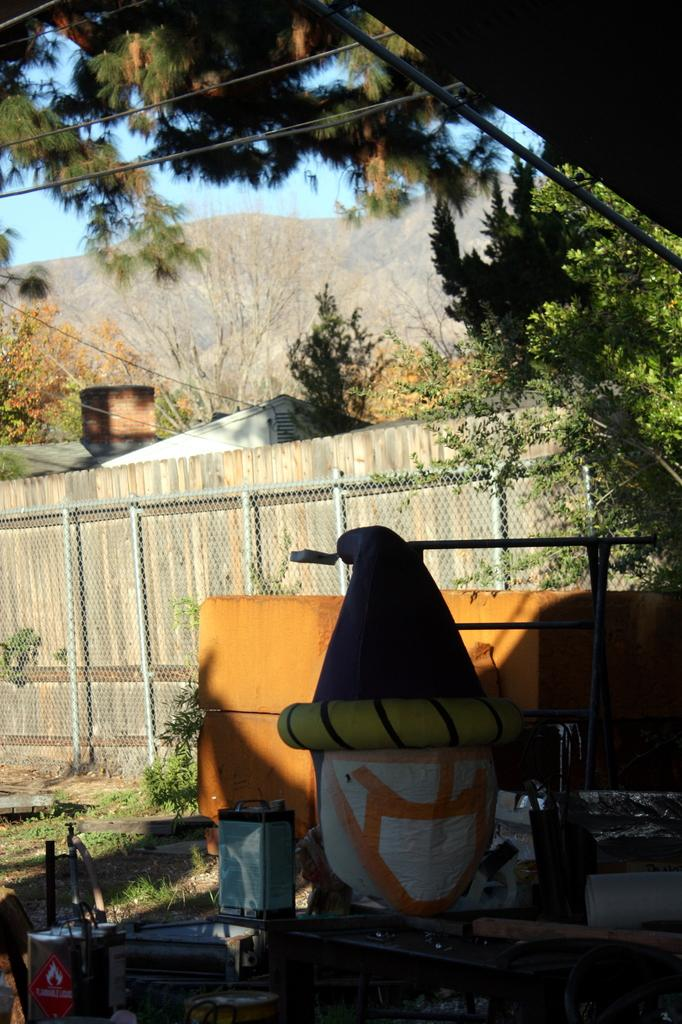What type of objects can be seen in the image? There are cans in the image. Can you describe the color of one of the objects in the image? There is a brown colored object in the image. What type of structure can be seen in the image? There is fencing and a wall in the image. What type of natural elements can be seen in the image? There are trees and a mountain visible in the image. What is visible in the background of the image? The sky is visible in the background of the image. Can you identify any man-made structures in the image? There is a house in the image. What type of theory can be seen being tested in the image? There is no theory being tested in the image; it contains cans, a brown object, fencing, a wall, trees, a house, a mountain, and the sky. Can you smell the scent of the bell in the image? There is no bell present in the image, so it is not possible to smell its scent. 